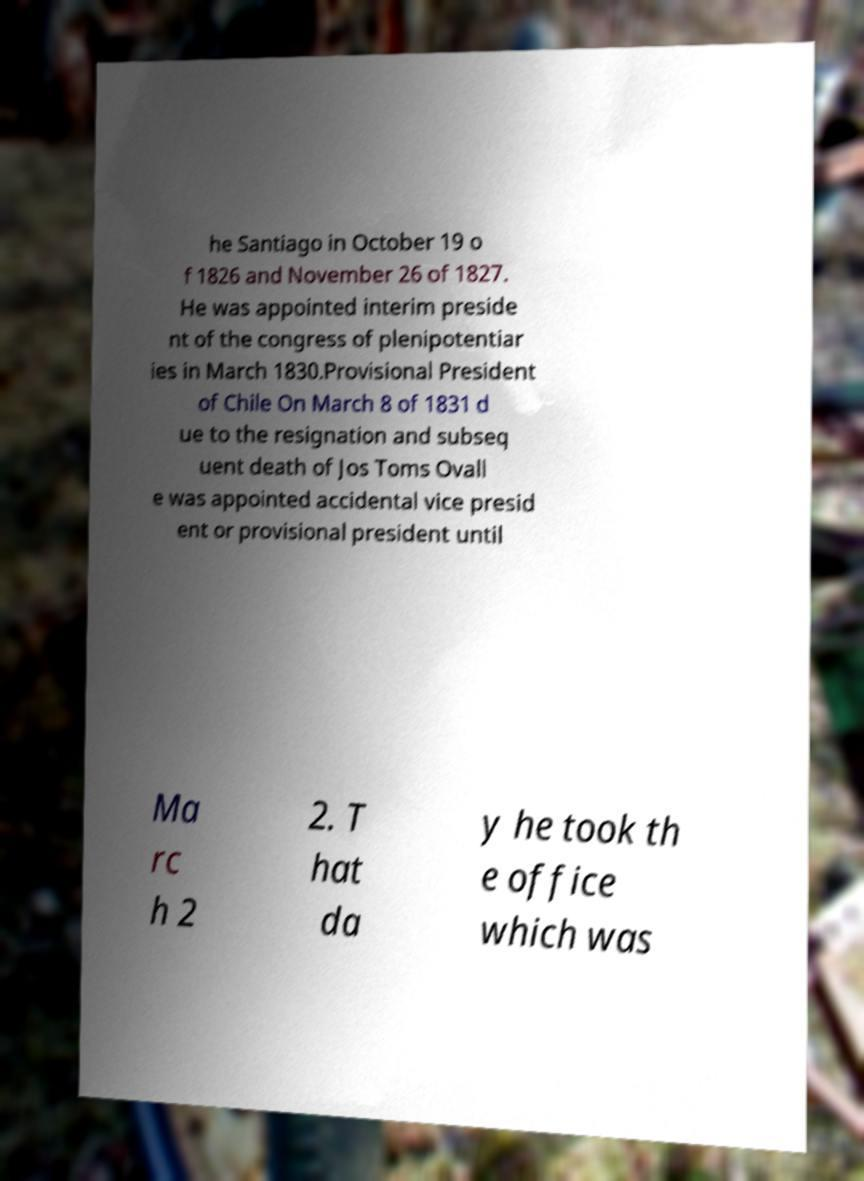What messages or text are displayed in this image? I need them in a readable, typed format. he Santiago in October 19 o f 1826 and November 26 of 1827. He was appointed interim preside nt of the congress of plenipotentiar ies in March 1830.Provisional President of Chile On March 8 of 1831 d ue to the resignation and subseq uent death of Jos Toms Ovall e was appointed accidental vice presid ent or provisional president until Ma rc h 2 2. T hat da y he took th e office which was 